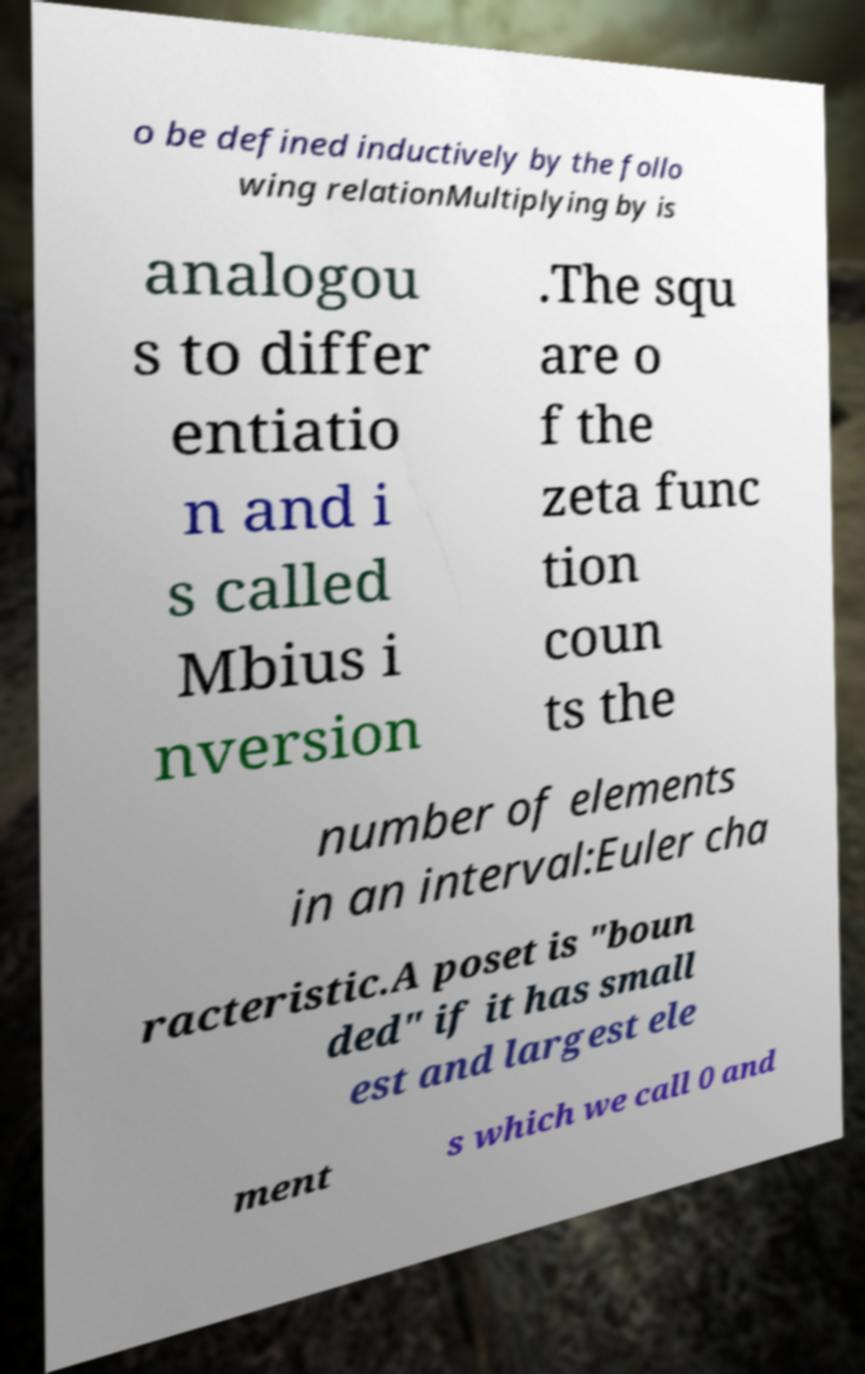There's text embedded in this image that I need extracted. Can you transcribe it verbatim? o be defined inductively by the follo wing relationMultiplying by is analogou s to differ entiatio n and i s called Mbius i nversion .The squ are o f the zeta func tion coun ts the number of elements in an interval:Euler cha racteristic.A poset is "boun ded" if it has small est and largest ele ment s which we call 0 and 